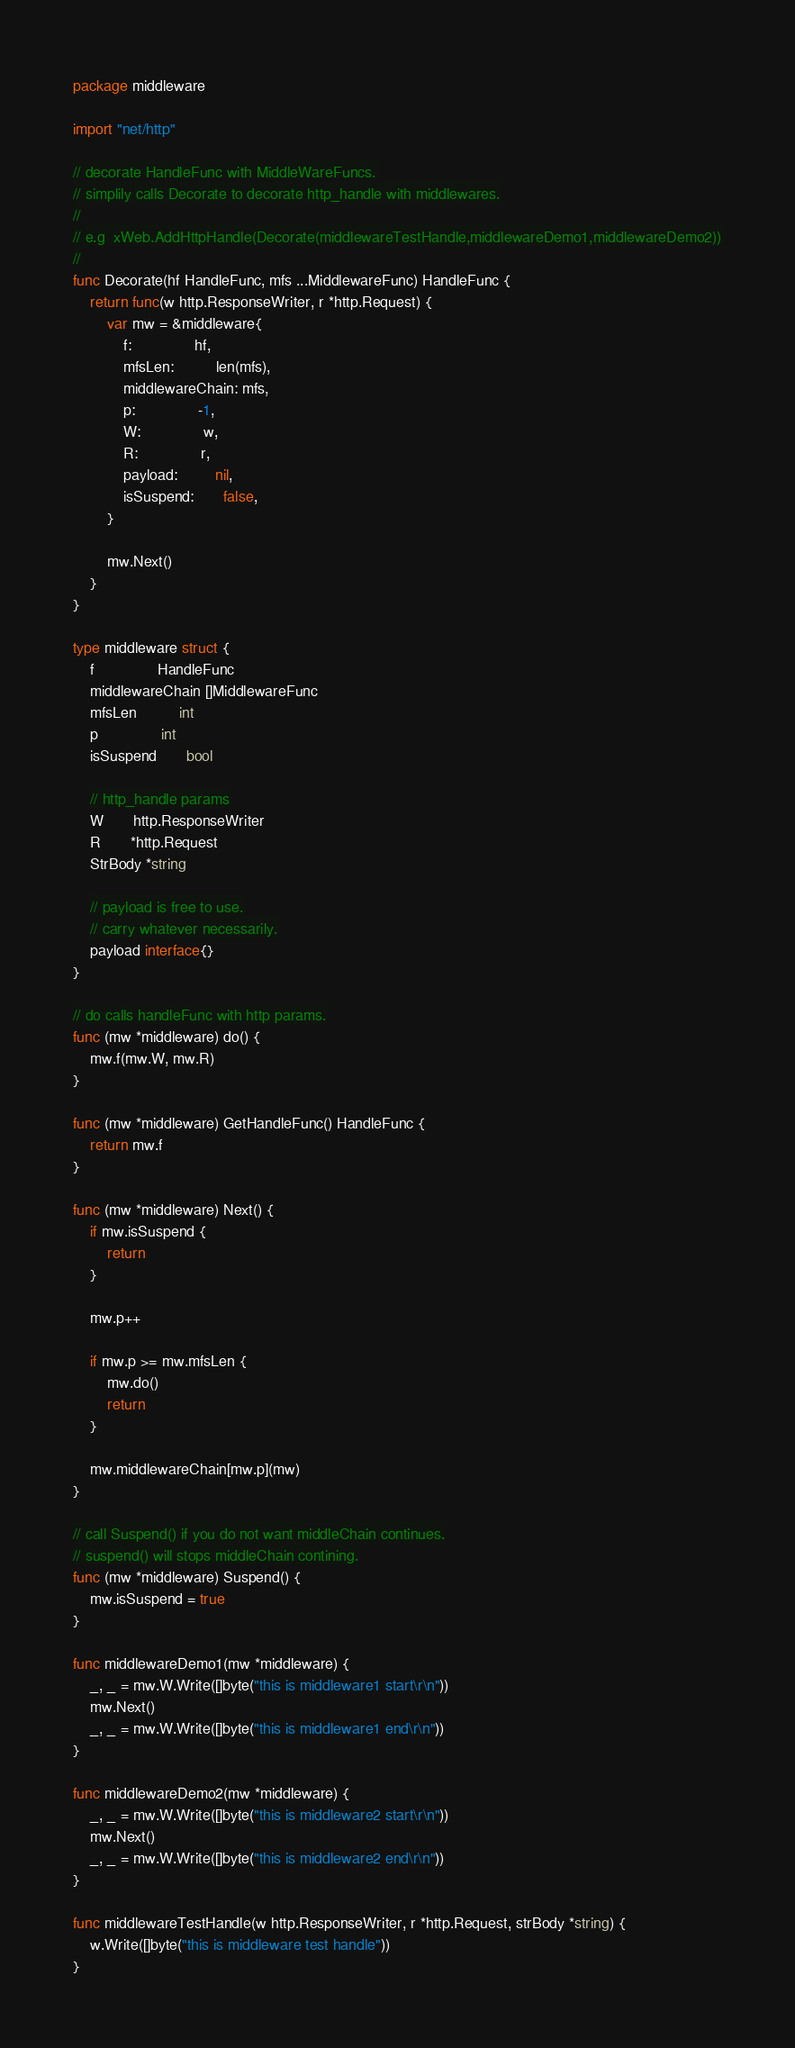Convert code to text. <code><loc_0><loc_0><loc_500><loc_500><_Go_>package middleware

import "net/http"

// decorate HandleFunc with MiddleWareFuncs.
// simplily calls Decorate to decorate http_handle with middlewares.
//
// e.g  xWeb.AddHttpHandle(Decorate(middlewareTestHandle,middlewareDemo1,middlewareDemo2))
//
func Decorate(hf HandleFunc, mfs ...MiddlewareFunc) HandleFunc {
	return func(w http.ResponseWriter, r *http.Request) {
		var mw = &middleware{
			f:               hf,
			mfsLen:          len(mfs),
			middlewareChain: mfs,
			p:               -1,
			W:               w,
			R:               r,
			payload:         nil,
			isSuspend:       false,
		}

		mw.Next()
	}
}

type middleware struct {
	f               HandleFunc
	middlewareChain []MiddlewareFunc
	mfsLen          int
	p               int
	isSuspend       bool

	// http_handle params
	W       http.ResponseWriter
	R       *http.Request
	StrBody *string

	// payload is free to use.
	// carry whatever necessarily.
	payload interface{}
}

// do calls handleFunc with http params.
func (mw *middleware) do() {
	mw.f(mw.W, mw.R)
}

func (mw *middleware) GetHandleFunc() HandleFunc {
	return mw.f
}

func (mw *middleware) Next() {
	if mw.isSuspend {
		return
	}

	mw.p++

	if mw.p >= mw.mfsLen {
		mw.do()
		return
	}

	mw.middlewareChain[mw.p](mw)
}

// call Suspend() if you do not want middleChain continues.
// suspend() will stops middleChain contining.
func (mw *middleware) Suspend() {
	mw.isSuspend = true
}

func middlewareDemo1(mw *middleware) {
	_, _ = mw.W.Write([]byte("this is middleware1 start\r\n"))
	mw.Next()
	_, _ = mw.W.Write([]byte("this is middleware1 end\r\n"))
}

func middlewareDemo2(mw *middleware) {
	_, _ = mw.W.Write([]byte("this is middleware2 start\r\n"))
	mw.Next()
	_, _ = mw.W.Write([]byte("this is middleware2 end\r\n"))
}

func middlewareTestHandle(w http.ResponseWriter, r *http.Request, strBody *string) {
	w.Write([]byte("this is middleware test handle"))
}
</code> 